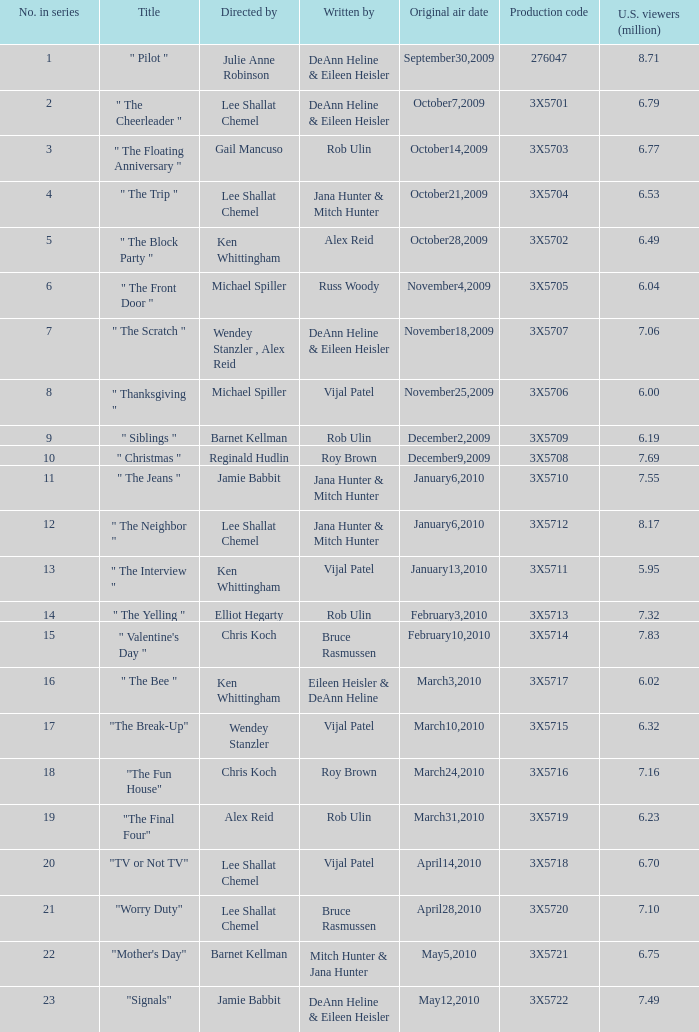95 million u.s. viewers? Vijal Patel. 